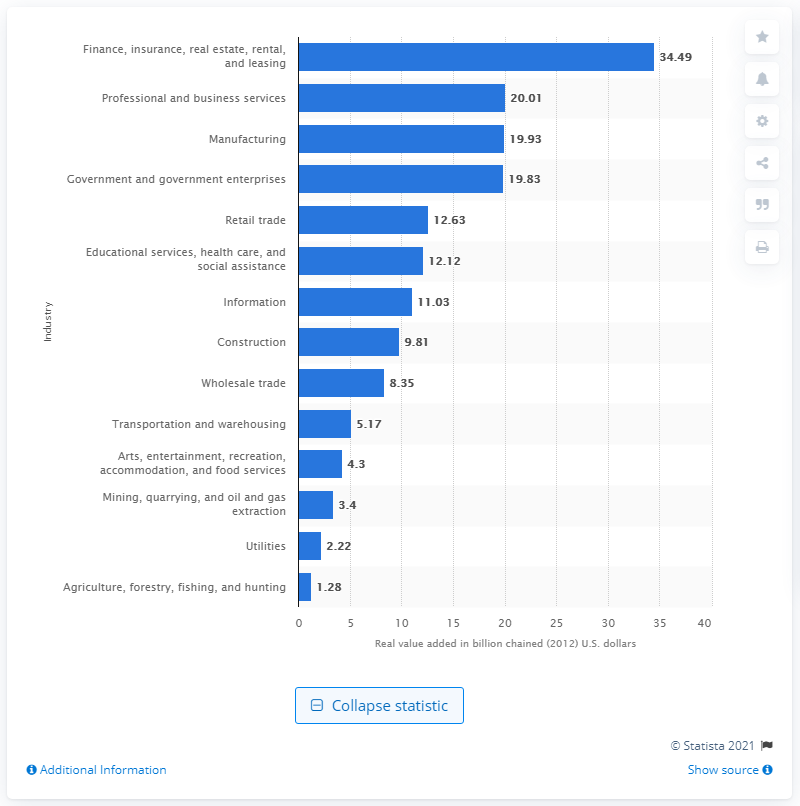Give some essential details in this illustration. In 2012, the finance, insurance, real estate, rental, and leasing industry contributed 34.49 dollars to the gross domestic product (GDP) of Utah. 